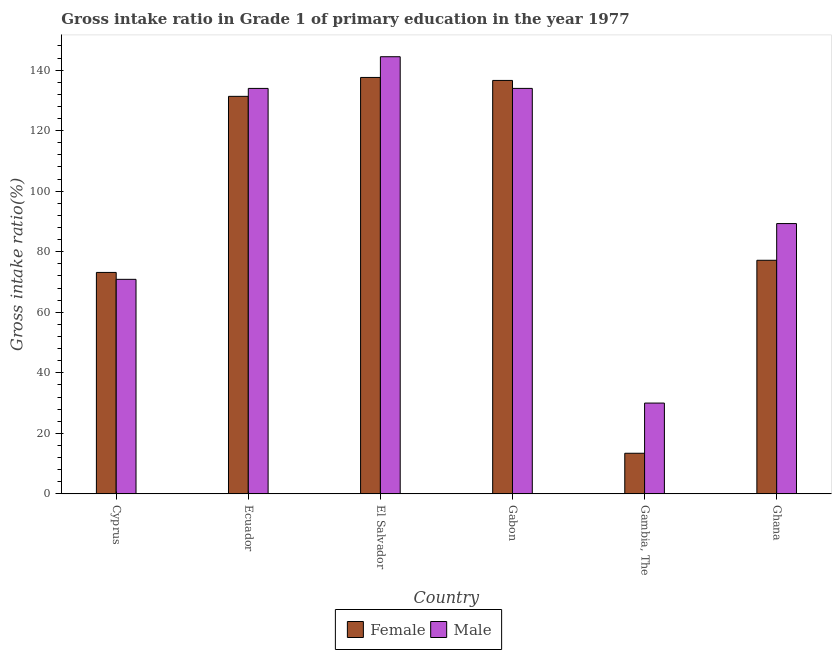How many different coloured bars are there?
Keep it short and to the point. 2. How many groups of bars are there?
Keep it short and to the point. 6. How many bars are there on the 6th tick from the right?
Provide a short and direct response. 2. What is the label of the 5th group of bars from the left?
Ensure brevity in your answer.  Gambia, The. In how many cases, is the number of bars for a given country not equal to the number of legend labels?
Offer a terse response. 0. What is the gross intake ratio(female) in El Salvador?
Offer a very short reply. 137.59. Across all countries, what is the maximum gross intake ratio(female)?
Provide a short and direct response. 137.59. Across all countries, what is the minimum gross intake ratio(male)?
Make the answer very short. 30. In which country was the gross intake ratio(male) maximum?
Your response must be concise. El Salvador. In which country was the gross intake ratio(female) minimum?
Your response must be concise. Gambia, The. What is the total gross intake ratio(male) in the graph?
Provide a succinct answer. 602.55. What is the difference between the gross intake ratio(female) in El Salvador and that in Gabon?
Your response must be concise. 0.98. What is the difference between the gross intake ratio(male) in Gambia, The and the gross intake ratio(female) in El Salvador?
Your answer should be very brief. -107.59. What is the average gross intake ratio(male) per country?
Make the answer very short. 100.42. What is the difference between the gross intake ratio(female) and gross intake ratio(male) in Cyprus?
Your answer should be very brief. 2.28. In how many countries, is the gross intake ratio(male) greater than 112 %?
Your answer should be very brief. 3. What is the ratio of the gross intake ratio(male) in Gambia, The to that in Ghana?
Offer a very short reply. 0.34. Is the gross intake ratio(male) in Cyprus less than that in Ecuador?
Make the answer very short. Yes. What is the difference between the highest and the second highest gross intake ratio(female)?
Make the answer very short. 0.98. What is the difference between the highest and the lowest gross intake ratio(male)?
Give a very brief answer. 114.43. In how many countries, is the gross intake ratio(female) greater than the average gross intake ratio(female) taken over all countries?
Your answer should be compact. 3. Is the sum of the gross intake ratio(male) in Gabon and Ghana greater than the maximum gross intake ratio(female) across all countries?
Offer a terse response. Yes. What does the 1st bar from the left in Ghana represents?
Ensure brevity in your answer.  Female. What does the 2nd bar from the right in Gambia, The represents?
Offer a terse response. Female. How many bars are there?
Ensure brevity in your answer.  12. How many countries are there in the graph?
Ensure brevity in your answer.  6. What is the difference between two consecutive major ticks on the Y-axis?
Offer a very short reply. 20. Does the graph contain any zero values?
Keep it short and to the point. No. Does the graph contain grids?
Your response must be concise. No. What is the title of the graph?
Ensure brevity in your answer.  Gross intake ratio in Grade 1 of primary education in the year 1977. What is the label or title of the Y-axis?
Give a very brief answer. Gross intake ratio(%). What is the Gross intake ratio(%) of Female in Cyprus?
Provide a short and direct response. 73.16. What is the Gross intake ratio(%) of Male in Cyprus?
Make the answer very short. 70.88. What is the Gross intake ratio(%) in Female in Ecuador?
Give a very brief answer. 131.34. What is the Gross intake ratio(%) in Male in Ecuador?
Give a very brief answer. 133.96. What is the Gross intake ratio(%) of Female in El Salvador?
Give a very brief answer. 137.59. What is the Gross intake ratio(%) of Male in El Salvador?
Provide a succinct answer. 144.43. What is the Gross intake ratio(%) in Female in Gabon?
Provide a short and direct response. 136.6. What is the Gross intake ratio(%) of Male in Gabon?
Your answer should be compact. 133.97. What is the Gross intake ratio(%) of Female in Gambia, The?
Provide a short and direct response. 13.42. What is the Gross intake ratio(%) of Male in Gambia, The?
Your answer should be very brief. 30. What is the Gross intake ratio(%) in Female in Ghana?
Make the answer very short. 77.18. What is the Gross intake ratio(%) in Male in Ghana?
Offer a very short reply. 89.3. Across all countries, what is the maximum Gross intake ratio(%) of Female?
Give a very brief answer. 137.59. Across all countries, what is the maximum Gross intake ratio(%) of Male?
Your answer should be compact. 144.43. Across all countries, what is the minimum Gross intake ratio(%) of Female?
Offer a terse response. 13.42. Across all countries, what is the minimum Gross intake ratio(%) in Male?
Provide a short and direct response. 30. What is the total Gross intake ratio(%) in Female in the graph?
Your answer should be very brief. 569.29. What is the total Gross intake ratio(%) of Male in the graph?
Offer a very short reply. 602.55. What is the difference between the Gross intake ratio(%) in Female in Cyprus and that in Ecuador?
Your response must be concise. -58.18. What is the difference between the Gross intake ratio(%) in Male in Cyprus and that in Ecuador?
Ensure brevity in your answer.  -63.08. What is the difference between the Gross intake ratio(%) of Female in Cyprus and that in El Salvador?
Your answer should be compact. -64.42. What is the difference between the Gross intake ratio(%) of Male in Cyprus and that in El Salvador?
Offer a terse response. -73.55. What is the difference between the Gross intake ratio(%) in Female in Cyprus and that in Gabon?
Keep it short and to the point. -63.44. What is the difference between the Gross intake ratio(%) in Male in Cyprus and that in Gabon?
Keep it short and to the point. -63.09. What is the difference between the Gross intake ratio(%) of Female in Cyprus and that in Gambia, The?
Offer a terse response. 59.75. What is the difference between the Gross intake ratio(%) in Male in Cyprus and that in Gambia, The?
Offer a terse response. 40.88. What is the difference between the Gross intake ratio(%) in Female in Cyprus and that in Ghana?
Keep it short and to the point. -4.02. What is the difference between the Gross intake ratio(%) in Male in Cyprus and that in Ghana?
Provide a short and direct response. -18.42. What is the difference between the Gross intake ratio(%) in Female in Ecuador and that in El Salvador?
Offer a very short reply. -6.25. What is the difference between the Gross intake ratio(%) in Male in Ecuador and that in El Salvador?
Provide a succinct answer. -10.47. What is the difference between the Gross intake ratio(%) of Female in Ecuador and that in Gabon?
Make the answer very short. -5.26. What is the difference between the Gross intake ratio(%) of Male in Ecuador and that in Gabon?
Offer a very short reply. -0.01. What is the difference between the Gross intake ratio(%) of Female in Ecuador and that in Gambia, The?
Offer a very short reply. 117.93. What is the difference between the Gross intake ratio(%) in Male in Ecuador and that in Gambia, The?
Your answer should be compact. 103.97. What is the difference between the Gross intake ratio(%) in Female in Ecuador and that in Ghana?
Provide a short and direct response. 54.16. What is the difference between the Gross intake ratio(%) of Male in Ecuador and that in Ghana?
Offer a very short reply. 44.66. What is the difference between the Gross intake ratio(%) in Male in El Salvador and that in Gabon?
Ensure brevity in your answer.  10.46. What is the difference between the Gross intake ratio(%) in Female in El Salvador and that in Gambia, The?
Provide a succinct answer. 124.17. What is the difference between the Gross intake ratio(%) in Male in El Salvador and that in Gambia, The?
Give a very brief answer. 114.43. What is the difference between the Gross intake ratio(%) in Female in El Salvador and that in Ghana?
Keep it short and to the point. 60.41. What is the difference between the Gross intake ratio(%) of Male in El Salvador and that in Ghana?
Give a very brief answer. 55.13. What is the difference between the Gross intake ratio(%) of Female in Gabon and that in Gambia, The?
Your response must be concise. 123.19. What is the difference between the Gross intake ratio(%) in Male in Gabon and that in Gambia, The?
Provide a short and direct response. 103.97. What is the difference between the Gross intake ratio(%) in Female in Gabon and that in Ghana?
Offer a terse response. 59.42. What is the difference between the Gross intake ratio(%) of Male in Gabon and that in Ghana?
Offer a terse response. 44.66. What is the difference between the Gross intake ratio(%) in Female in Gambia, The and that in Ghana?
Offer a terse response. -63.76. What is the difference between the Gross intake ratio(%) of Male in Gambia, The and that in Ghana?
Provide a short and direct response. -59.31. What is the difference between the Gross intake ratio(%) of Female in Cyprus and the Gross intake ratio(%) of Male in Ecuador?
Ensure brevity in your answer.  -60.8. What is the difference between the Gross intake ratio(%) in Female in Cyprus and the Gross intake ratio(%) in Male in El Salvador?
Your answer should be very brief. -71.27. What is the difference between the Gross intake ratio(%) of Female in Cyprus and the Gross intake ratio(%) of Male in Gabon?
Your answer should be compact. -60.8. What is the difference between the Gross intake ratio(%) of Female in Cyprus and the Gross intake ratio(%) of Male in Gambia, The?
Your answer should be compact. 43.17. What is the difference between the Gross intake ratio(%) of Female in Cyprus and the Gross intake ratio(%) of Male in Ghana?
Your response must be concise. -16.14. What is the difference between the Gross intake ratio(%) in Female in Ecuador and the Gross intake ratio(%) in Male in El Salvador?
Provide a succinct answer. -13.09. What is the difference between the Gross intake ratio(%) of Female in Ecuador and the Gross intake ratio(%) of Male in Gabon?
Offer a very short reply. -2.63. What is the difference between the Gross intake ratio(%) of Female in Ecuador and the Gross intake ratio(%) of Male in Gambia, The?
Provide a short and direct response. 101.34. What is the difference between the Gross intake ratio(%) in Female in Ecuador and the Gross intake ratio(%) in Male in Ghana?
Ensure brevity in your answer.  42.04. What is the difference between the Gross intake ratio(%) of Female in El Salvador and the Gross intake ratio(%) of Male in Gabon?
Offer a very short reply. 3.62. What is the difference between the Gross intake ratio(%) in Female in El Salvador and the Gross intake ratio(%) in Male in Gambia, The?
Your answer should be compact. 107.59. What is the difference between the Gross intake ratio(%) of Female in El Salvador and the Gross intake ratio(%) of Male in Ghana?
Keep it short and to the point. 48.28. What is the difference between the Gross intake ratio(%) in Female in Gabon and the Gross intake ratio(%) in Male in Gambia, The?
Give a very brief answer. 106.61. What is the difference between the Gross intake ratio(%) in Female in Gabon and the Gross intake ratio(%) in Male in Ghana?
Your answer should be very brief. 47.3. What is the difference between the Gross intake ratio(%) in Female in Gambia, The and the Gross intake ratio(%) in Male in Ghana?
Your answer should be compact. -75.89. What is the average Gross intake ratio(%) of Female per country?
Offer a very short reply. 94.88. What is the average Gross intake ratio(%) in Male per country?
Provide a short and direct response. 100.42. What is the difference between the Gross intake ratio(%) of Female and Gross intake ratio(%) of Male in Cyprus?
Keep it short and to the point. 2.28. What is the difference between the Gross intake ratio(%) in Female and Gross intake ratio(%) in Male in Ecuador?
Offer a terse response. -2.62. What is the difference between the Gross intake ratio(%) in Female and Gross intake ratio(%) in Male in El Salvador?
Keep it short and to the point. -6.84. What is the difference between the Gross intake ratio(%) in Female and Gross intake ratio(%) in Male in Gabon?
Offer a terse response. 2.63. What is the difference between the Gross intake ratio(%) of Female and Gross intake ratio(%) of Male in Gambia, The?
Your answer should be compact. -16.58. What is the difference between the Gross intake ratio(%) in Female and Gross intake ratio(%) in Male in Ghana?
Keep it short and to the point. -12.13. What is the ratio of the Gross intake ratio(%) in Female in Cyprus to that in Ecuador?
Ensure brevity in your answer.  0.56. What is the ratio of the Gross intake ratio(%) of Male in Cyprus to that in Ecuador?
Offer a very short reply. 0.53. What is the ratio of the Gross intake ratio(%) in Female in Cyprus to that in El Salvador?
Your answer should be very brief. 0.53. What is the ratio of the Gross intake ratio(%) of Male in Cyprus to that in El Salvador?
Provide a succinct answer. 0.49. What is the ratio of the Gross intake ratio(%) in Female in Cyprus to that in Gabon?
Offer a terse response. 0.54. What is the ratio of the Gross intake ratio(%) in Male in Cyprus to that in Gabon?
Your answer should be compact. 0.53. What is the ratio of the Gross intake ratio(%) in Female in Cyprus to that in Gambia, The?
Offer a terse response. 5.45. What is the ratio of the Gross intake ratio(%) in Male in Cyprus to that in Gambia, The?
Offer a terse response. 2.36. What is the ratio of the Gross intake ratio(%) of Female in Cyprus to that in Ghana?
Provide a succinct answer. 0.95. What is the ratio of the Gross intake ratio(%) of Male in Cyprus to that in Ghana?
Provide a succinct answer. 0.79. What is the ratio of the Gross intake ratio(%) in Female in Ecuador to that in El Salvador?
Keep it short and to the point. 0.95. What is the ratio of the Gross intake ratio(%) of Male in Ecuador to that in El Salvador?
Your answer should be compact. 0.93. What is the ratio of the Gross intake ratio(%) of Female in Ecuador to that in Gabon?
Your response must be concise. 0.96. What is the ratio of the Gross intake ratio(%) in Male in Ecuador to that in Gabon?
Give a very brief answer. 1. What is the ratio of the Gross intake ratio(%) in Female in Ecuador to that in Gambia, The?
Keep it short and to the point. 9.79. What is the ratio of the Gross intake ratio(%) of Male in Ecuador to that in Gambia, The?
Give a very brief answer. 4.47. What is the ratio of the Gross intake ratio(%) in Female in Ecuador to that in Ghana?
Your answer should be compact. 1.7. What is the ratio of the Gross intake ratio(%) of Male in Ecuador to that in Ghana?
Your answer should be compact. 1.5. What is the ratio of the Gross intake ratio(%) of Female in El Salvador to that in Gabon?
Provide a short and direct response. 1.01. What is the ratio of the Gross intake ratio(%) of Male in El Salvador to that in Gabon?
Your answer should be very brief. 1.08. What is the ratio of the Gross intake ratio(%) of Female in El Salvador to that in Gambia, The?
Your answer should be compact. 10.26. What is the ratio of the Gross intake ratio(%) in Male in El Salvador to that in Gambia, The?
Your answer should be very brief. 4.81. What is the ratio of the Gross intake ratio(%) of Female in El Salvador to that in Ghana?
Keep it short and to the point. 1.78. What is the ratio of the Gross intake ratio(%) of Male in El Salvador to that in Ghana?
Your answer should be very brief. 1.62. What is the ratio of the Gross intake ratio(%) of Female in Gabon to that in Gambia, The?
Keep it short and to the point. 10.18. What is the ratio of the Gross intake ratio(%) in Male in Gabon to that in Gambia, The?
Your answer should be compact. 4.47. What is the ratio of the Gross intake ratio(%) of Female in Gabon to that in Ghana?
Offer a terse response. 1.77. What is the ratio of the Gross intake ratio(%) in Male in Gabon to that in Ghana?
Keep it short and to the point. 1.5. What is the ratio of the Gross intake ratio(%) of Female in Gambia, The to that in Ghana?
Give a very brief answer. 0.17. What is the ratio of the Gross intake ratio(%) in Male in Gambia, The to that in Ghana?
Your response must be concise. 0.34. What is the difference between the highest and the second highest Gross intake ratio(%) of Male?
Ensure brevity in your answer.  10.46. What is the difference between the highest and the lowest Gross intake ratio(%) of Female?
Your response must be concise. 124.17. What is the difference between the highest and the lowest Gross intake ratio(%) in Male?
Your answer should be very brief. 114.43. 